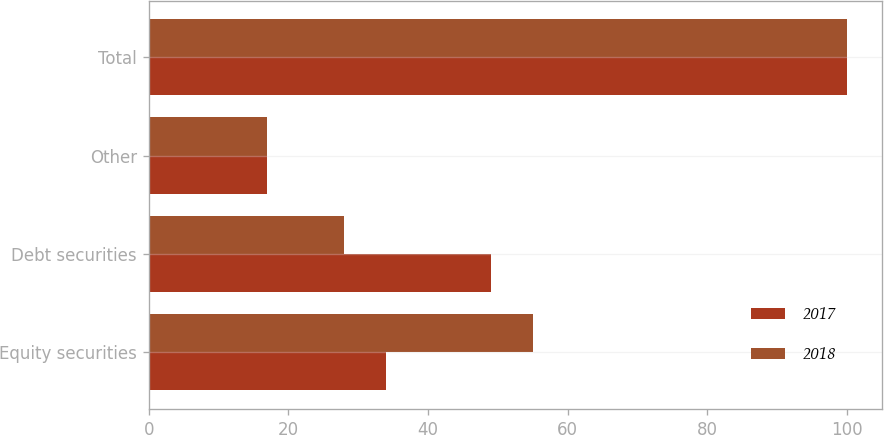Convert chart. <chart><loc_0><loc_0><loc_500><loc_500><stacked_bar_chart><ecel><fcel>Equity securities<fcel>Debt securities<fcel>Other<fcel>Total<nl><fcel>2017<fcel>34<fcel>49<fcel>17<fcel>100<nl><fcel>2018<fcel>55<fcel>28<fcel>17<fcel>100<nl></chart> 